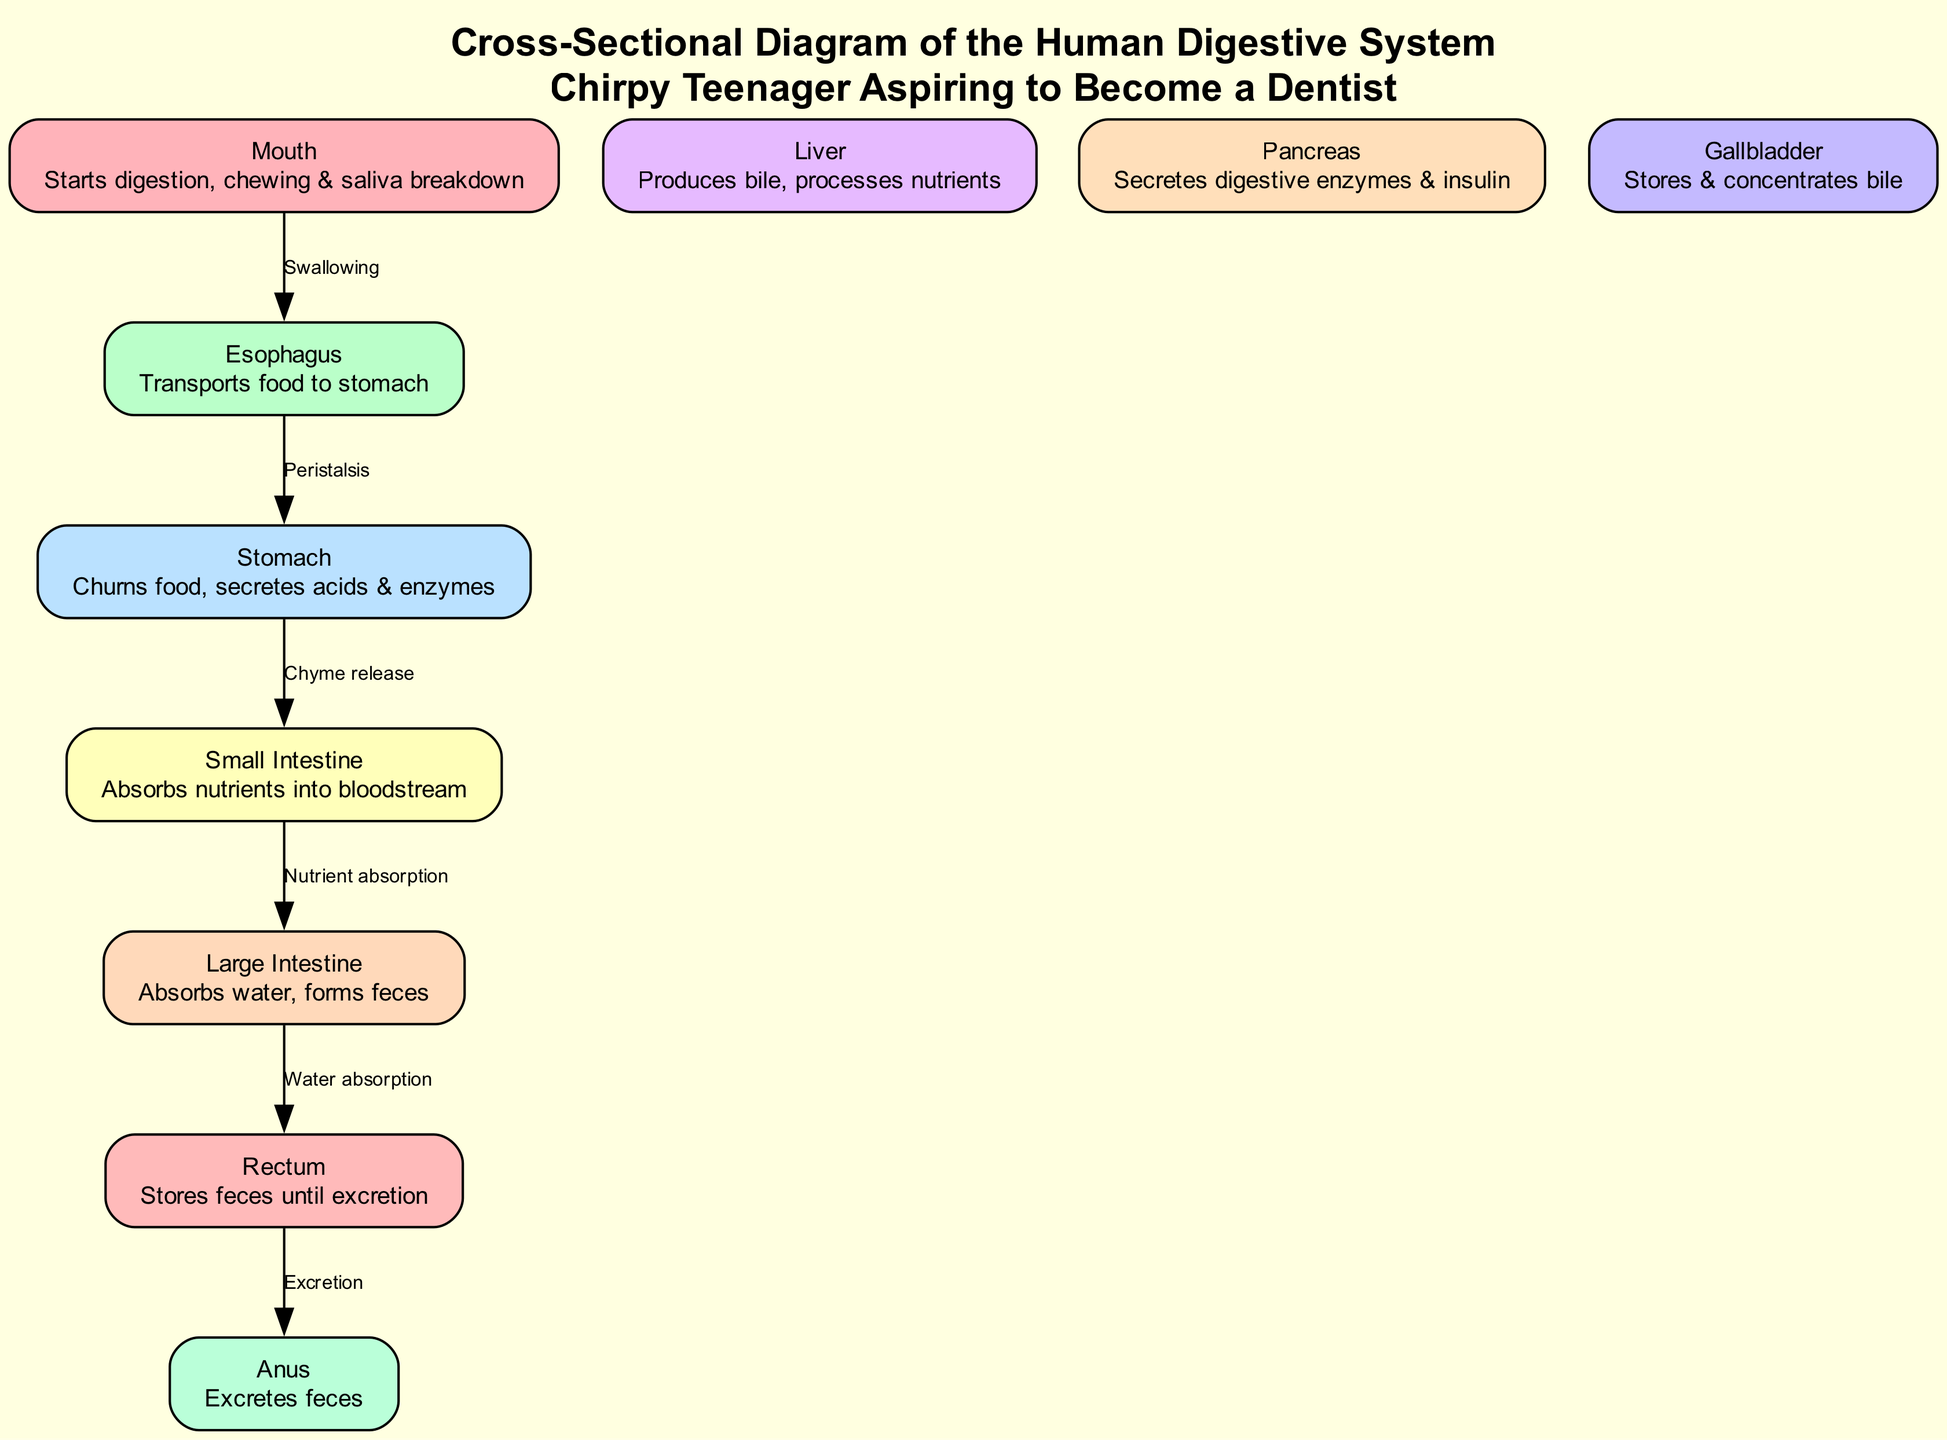What is the first organ in the digestive system? By looking at the diagram, the first organ is the "Mouth," which is labeled at the top of the diagram.
Answer: Mouth How many major organs are depicted in the diagram? The diagram lists ten major organs: mouth, esophagus, stomach, small intestine, large intestine, liver, pancreas, gallbladder, rectum, and anus. Counting each of them gives a total of ten.
Answer: 10 What process happens between the esophagus and the stomach? The diagram shows an edge labeled "Peristalsis" connecting the esophagus to the stomach, indicating this process is responsible for moving food from the esophagus to the stomach.
Answer: Peristalsis Which organ is responsible for nutrient absorption? The diagram specifically highlights the "Small Intestine" as the organ responsible for nutrient absorption into the bloodstream, based on its description.
Answer: Small Intestine What does the liver produce? In the diagram, the liver is described as producing "bile," which is explicitly mentioned in its description section.
Answer: Bile What is the final organ mentioned for excretion? According to the diagram, the final organ mentioned for excretion is the "Anus," which is indicated at the lowest point of the diagram and is labeled for its role.
Answer: Anus Which two organs are involved in storing substances? The diagram describes the "Gallbladder," which stores bile, and the "Rectum," which stores feces until excretion, linking both functions of storage to these organs.
Answer: Gallbladder and Rectum In what order do we see the flow of food from the mouth to the stomach? The flow of food begins at the "Mouth," moves through "Swallowing" to the "Esophagus," and continues to the "Stomach" as shown by the connecting edges in the diagram.
Answer: Mouth → Esophagus → Stomach How does the large intestine contribute to digestion? The large intestine's role is explicitly noted in the diagram as absorbing water and forming feces, which is crucial for the waste management process in digestion.
Answer: Absorbs water and forms feces 